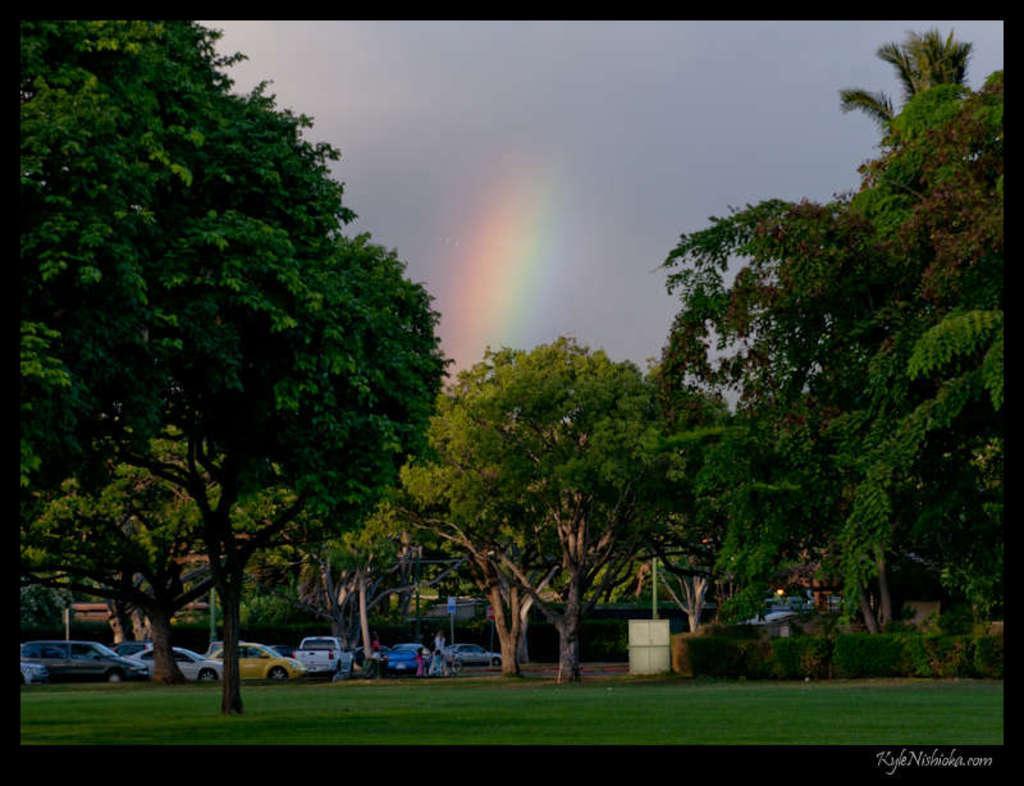Could you give a brief overview of what you see in this image? In the picture I can see trees, the grass, vehicles and people on the ground. In the background I can see the sky and the rainbow. 